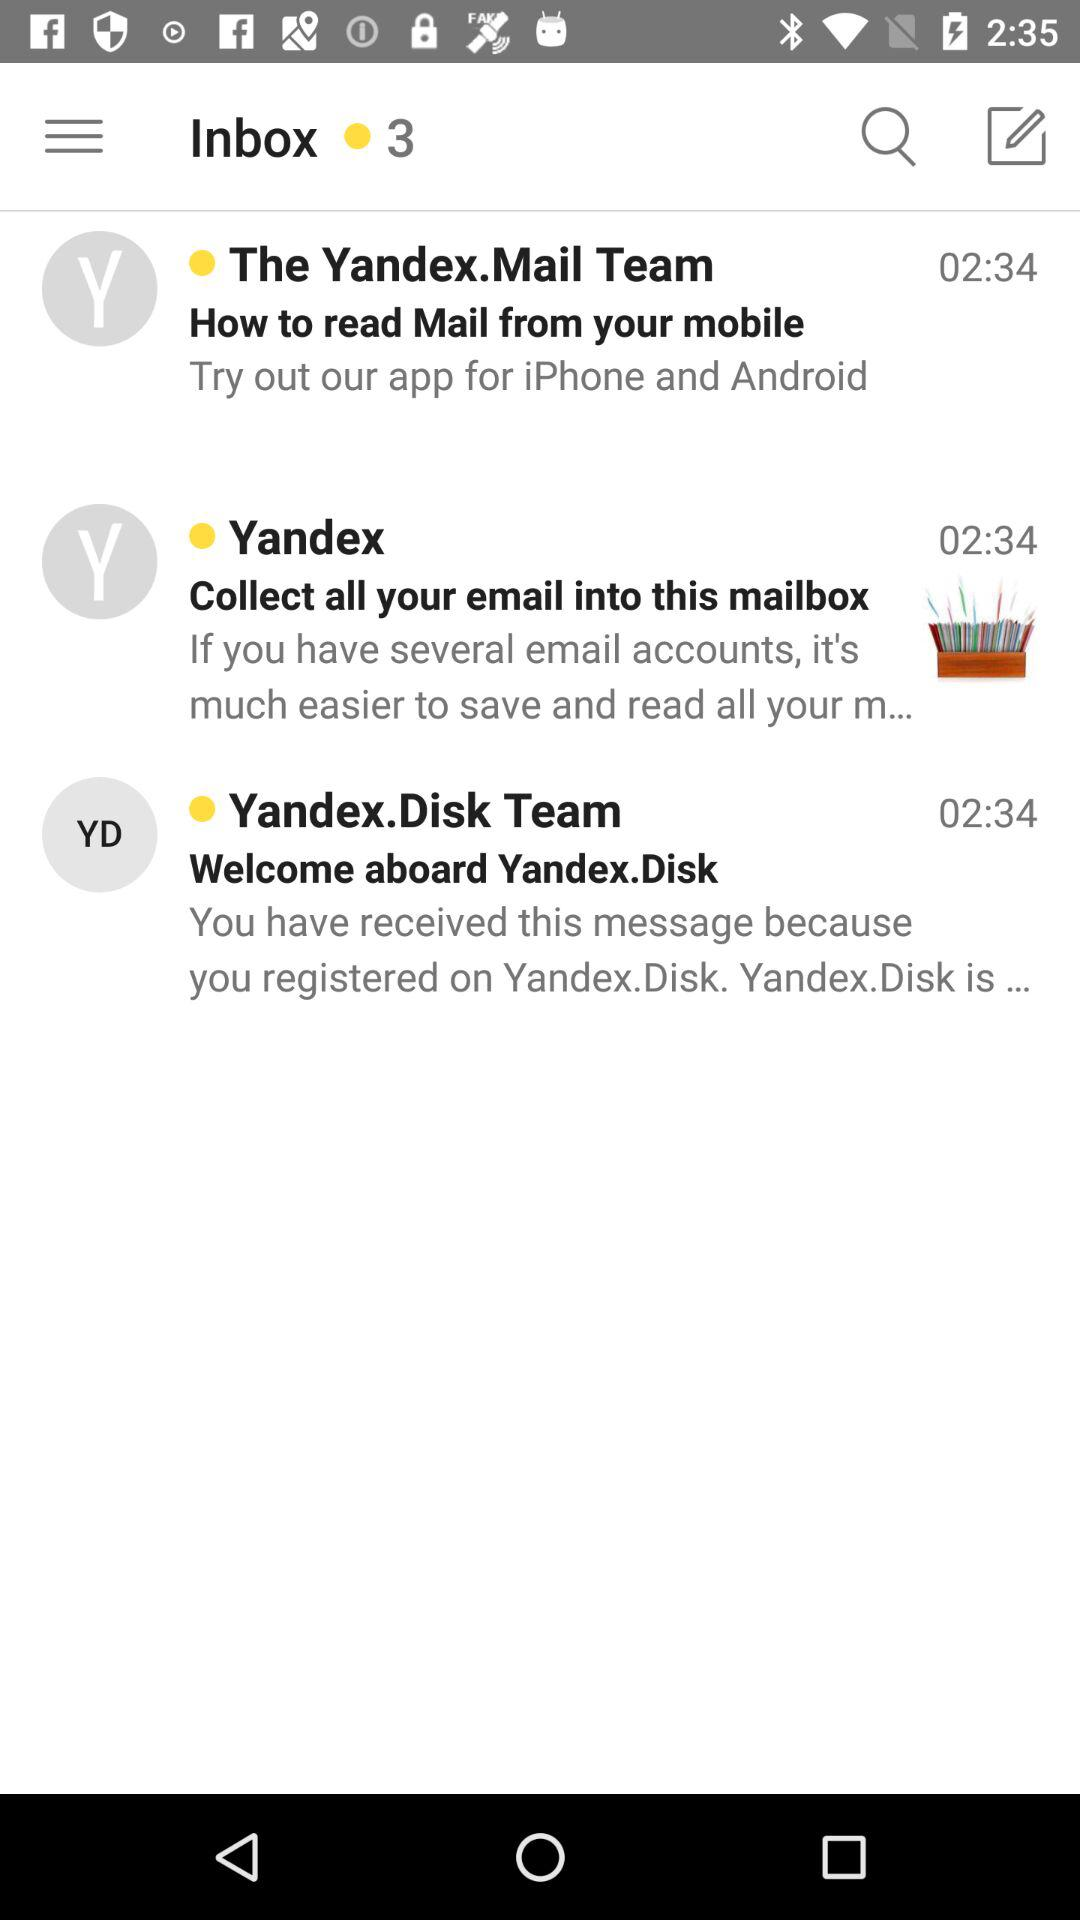How many messages are in the inbox?
Answer the question using a single word or phrase. 3 